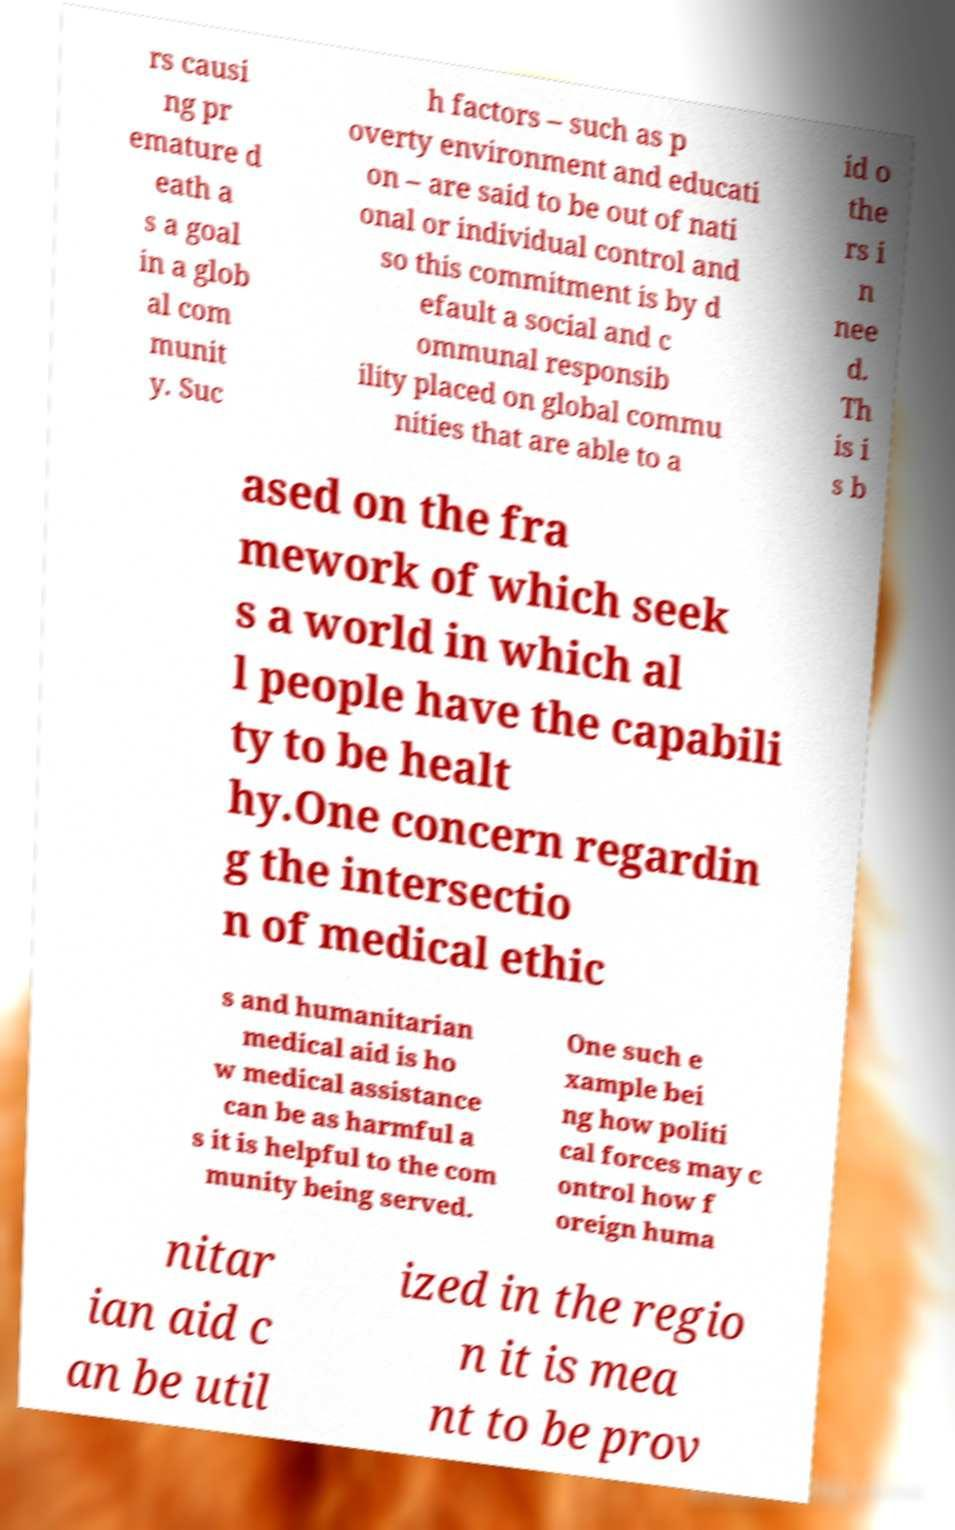Could you extract and type out the text from this image? rs causi ng pr emature d eath a s a goal in a glob al com munit y. Suc h factors – such as p overty environment and educati on – are said to be out of nati onal or individual control and so this commitment is by d efault a social and c ommunal responsib ility placed on global commu nities that are able to a id o the rs i n nee d. Th is i s b ased on the fra mework of which seek s a world in which al l people have the capabili ty to be healt hy.One concern regardin g the intersectio n of medical ethic s and humanitarian medical aid is ho w medical assistance can be as harmful a s it is helpful to the com munity being served. One such e xample bei ng how politi cal forces may c ontrol how f oreign huma nitar ian aid c an be util ized in the regio n it is mea nt to be prov 